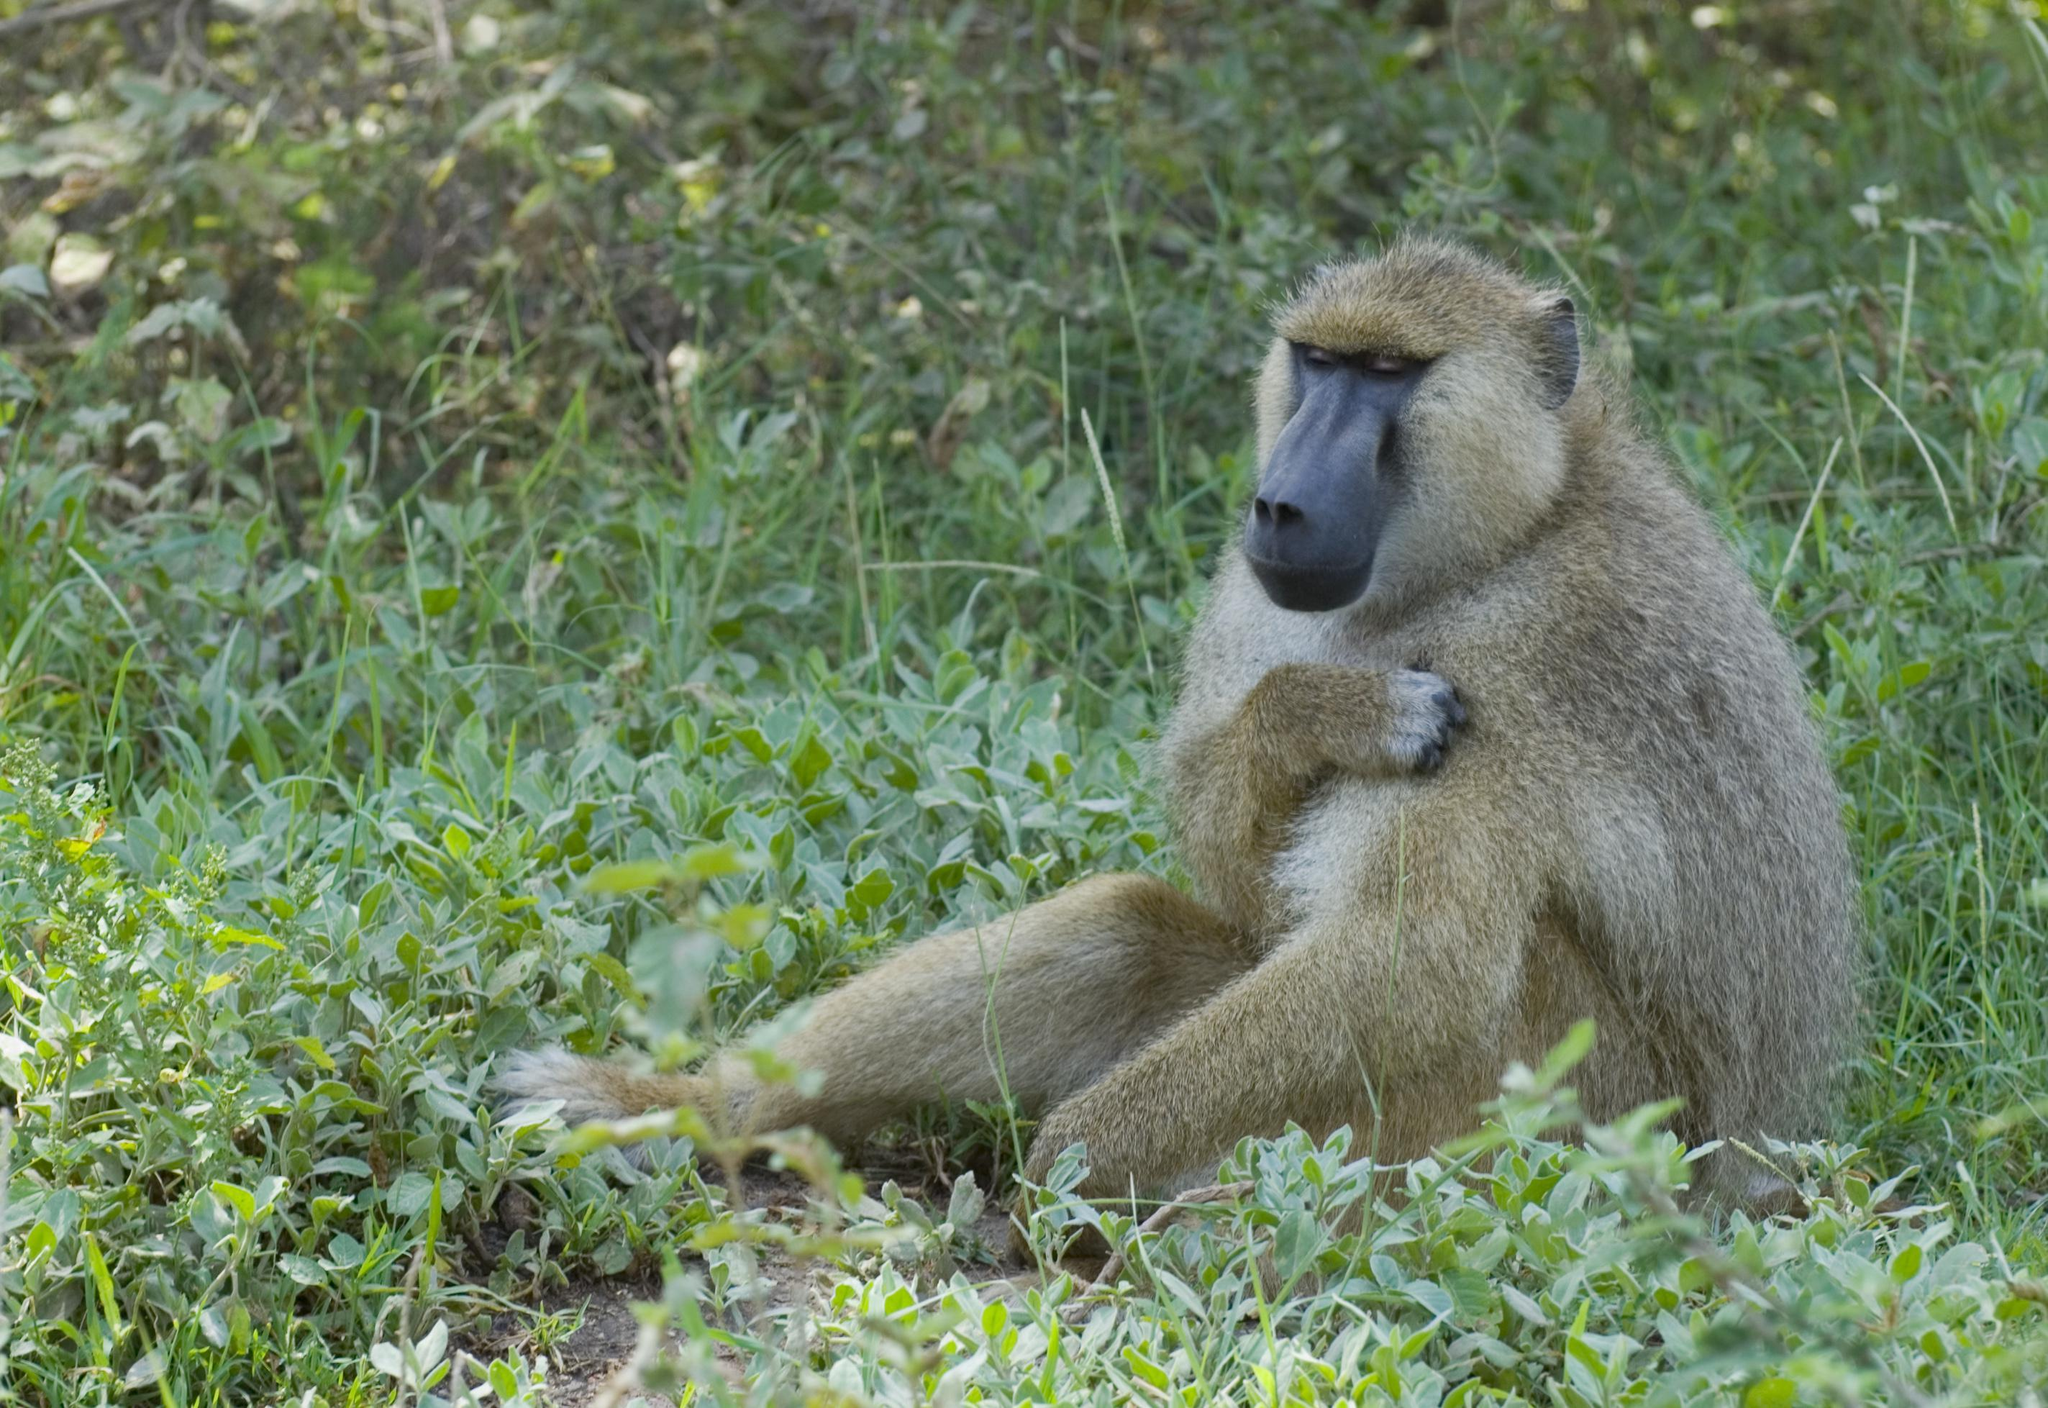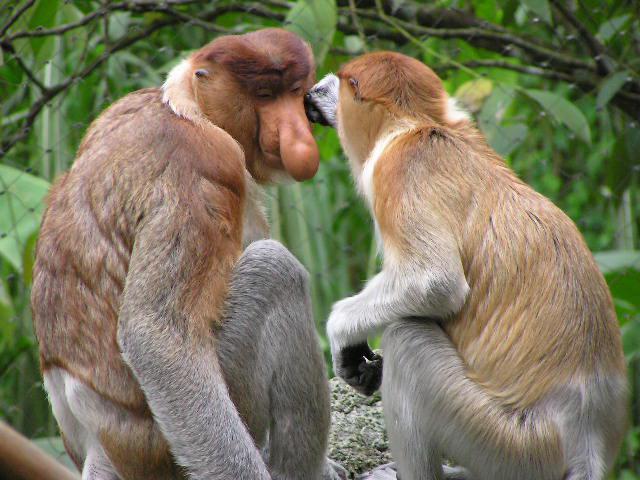The first image is the image on the left, the second image is the image on the right. Analyze the images presented: Is the assertion "At least one monkey is on all fours." valid? Answer yes or no. No. 